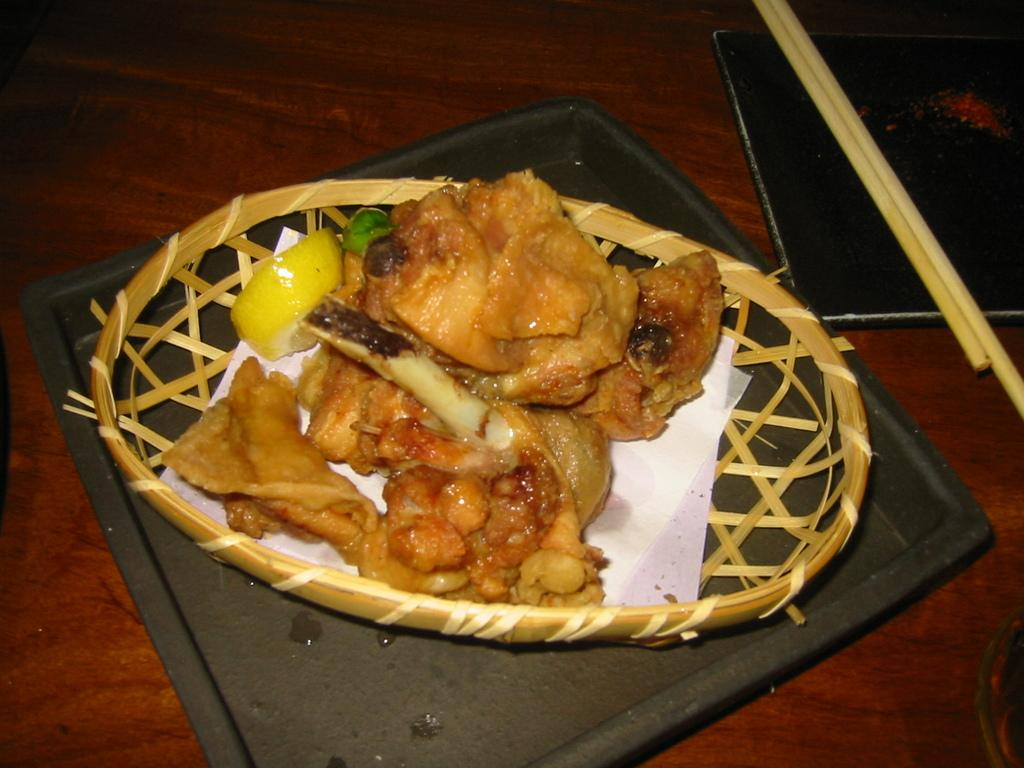What type of food item can be seen in the image? There is a food item in the image, but the specific type is not mentioned. Where are the tissues located in the image? The tissues are present in a basket in the image. What is the basket placed on? The basket is on a plate in the image. What utensils are visible in the image? Chopsticks are on another plate in the image. Where are the plates and chopsticks located? The plates and chopsticks are on a table in the image. What is the opinion of the food item in the image? The image does not convey any opinions about the food item; it only shows its presence. How much force is being applied to the chopsticks in the image? There is no indication of force being applied to the chopsticks in the image; they are simply resting on the plate. 